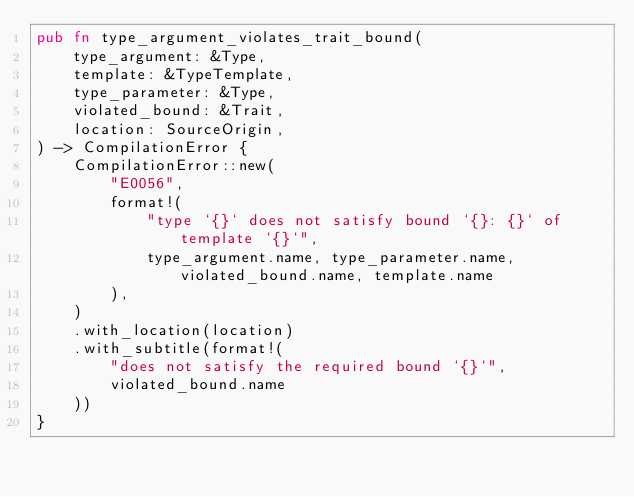Convert code to text. <code><loc_0><loc_0><loc_500><loc_500><_Rust_>pub fn type_argument_violates_trait_bound(
    type_argument: &Type,
    template: &TypeTemplate,
    type_parameter: &Type,
    violated_bound: &Trait,
    location: SourceOrigin,
) -> CompilationError {
    CompilationError::new(
        "E0056",
        format!(
            "type `{}` does not satisfy bound `{}: {}` of template `{}`",
            type_argument.name, type_parameter.name, violated_bound.name, template.name
        ),
    )
    .with_location(location)
    .with_subtitle(format!(
        "does not satisfy the required bound `{}`",
        violated_bound.name
    ))
}
</code> 